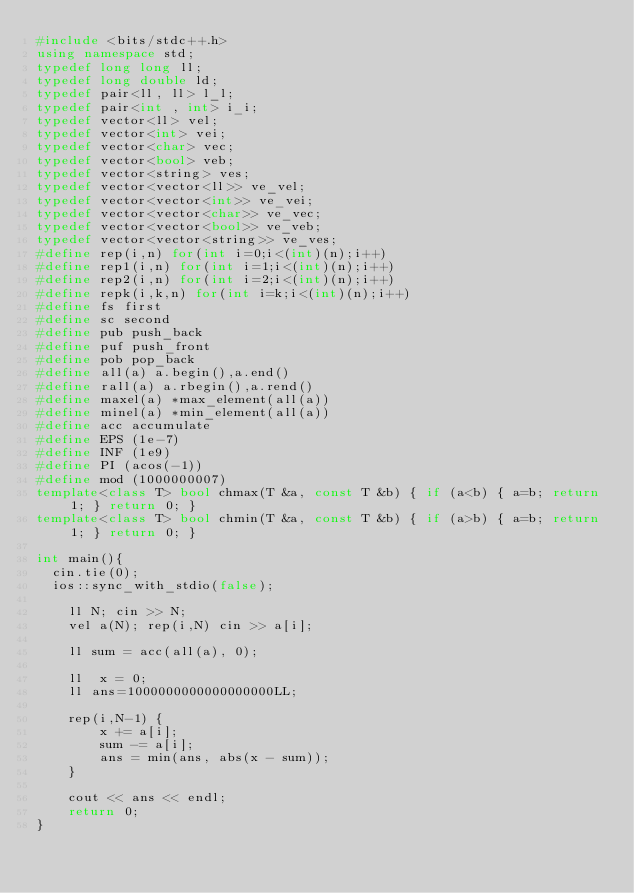<code> <loc_0><loc_0><loc_500><loc_500><_C++_>#include <bits/stdc++.h>
using namespace std;
typedef long long ll;
typedef long double ld;
typedef pair<ll, ll> l_l;
typedef pair<int , int> i_i;
typedef vector<ll> vel;
typedef vector<int> vei;
typedef vector<char> vec;
typedef vector<bool> veb;
typedef vector<string> ves;
typedef vector<vector<ll>> ve_vel;
typedef vector<vector<int>> ve_vei;
typedef vector<vector<char>> ve_vec;
typedef vector<vector<bool>> ve_veb;
typedef vector<vector<string>> ve_ves;
#define rep(i,n) for(int i=0;i<(int)(n);i++)
#define rep1(i,n) for(int i=1;i<(int)(n);i++)
#define rep2(i,n) for(int i=2;i<(int)(n);i++)
#define repk(i,k,n) for(int i=k;i<(int)(n);i++)
#define fs first
#define sc second
#define pub push_back
#define puf push_front
#define pob pop_back
#define all(a) a.begin(),a.end()
#define rall(a) a.rbegin(),a.rend()
#define maxel(a) *max_element(all(a))
#define minel(a) *min_element(all(a))
#define acc accumulate
#define EPS (1e-7)
#define INF (1e9)
#define PI (acos(-1))
#define mod (1000000007)
template<class T> bool chmax(T &a, const T &b) { if (a<b) { a=b; return 1; } return 0; }
template<class T> bool chmin(T &a, const T &b) { if (a>b) { a=b; return 1; } return 0; }

int main(){
	cin.tie(0);
	ios::sync_with_stdio(false);
 
    ll N; cin >> N;
    vel a(N); rep(i,N) cin >> a[i];
 
    ll sum = acc(all(a), 0);
 
    ll  x = 0;
    ll ans=1000000000000000000LL;
 
    rep(i,N-1) {
        x += a[i];
        sum -= a[i];
        ans = min(ans, abs(x - sum));
    }
 
    cout << ans << endl;
    return 0;
}
</code> 